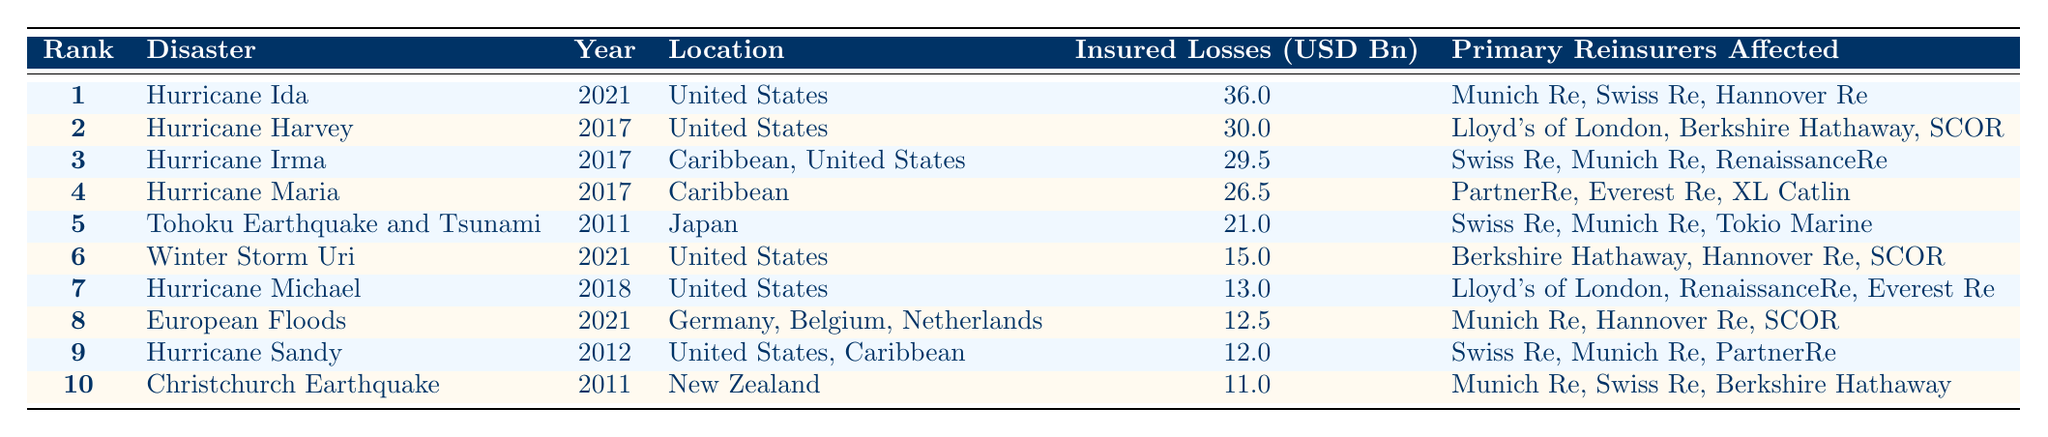What was the insured loss of Hurricane Ida? The table lists Hurricane Ida with insured losses of 36.0 billion USD in the Year 2021.
Answer: 36.0 billion USD Which disaster had the least insured losses? The least insured losses in the table are attributed to the Christchurch Earthquake, with losses of 11.0 billion USD in 2011.
Answer: Christchurch Earthquake How many disasters occurred in the year 2017? To find the answer, count the entries with the year 2017. The table shows four disasters: Hurricane Harvey, Hurricane Irma, Hurricane Maria, and Tohoku Earthquake and Tsunami.
Answer: 4 What is the total insured loss from all disasters listed? The total insured losses can be calculated by adding all the insured losses: (36.0 + 30.0 + 29.5 + 26.5 + 21.0 + 15.0 + 13.0 + 12.5 + 12.0 + 11.0) =  295.5 billion USD.
Answer: 295.5 billion USD Did any disaster in the table result in insured losses exceeding 30 billion USD? By reviewing the table, Hurricane Ida (36.0 billion USD) and Hurricane Harvey (30.0 billion USD) both exceed 30 billion USD.
Answer: Yes Which primary reinsurer appears most frequently among the disasters in the table? By checking the primary reinsurers listed, Munich Re appears in several disasters: Hurricane Ida, Hurricane Irma, Tohoku Earthquake and Tsunami, European Floods, Hurricane Sandy, and Christchurch Earthquake.
Answer: Munich Re What is the average insured loss of the disasters occurring in the United States? For the average, identify the disasters in the U.S. and their losses: Hurricane Ida (36.0), Hurricane Harvey (30.0), Winter Storm Uri (15.0), Hurricane Michael (13.0), Hurricane Sandy (12.0). The sum is 106.0 billion USD; there are 5 disasters, so average is 106.0/5 = 21.2 billion USD.
Answer: 21.2 billion USD How much higher was the insured loss of Hurricane Maria compared to Hurricane Michael? Look at the insured losses: Hurricane Maria has losses of 26.5 billion USD and Hurricane Michael has 13.0 billion USD. The difference is 26.5 - 13.0 = 13.5 billion USD.
Answer: 13.5 billion USD 